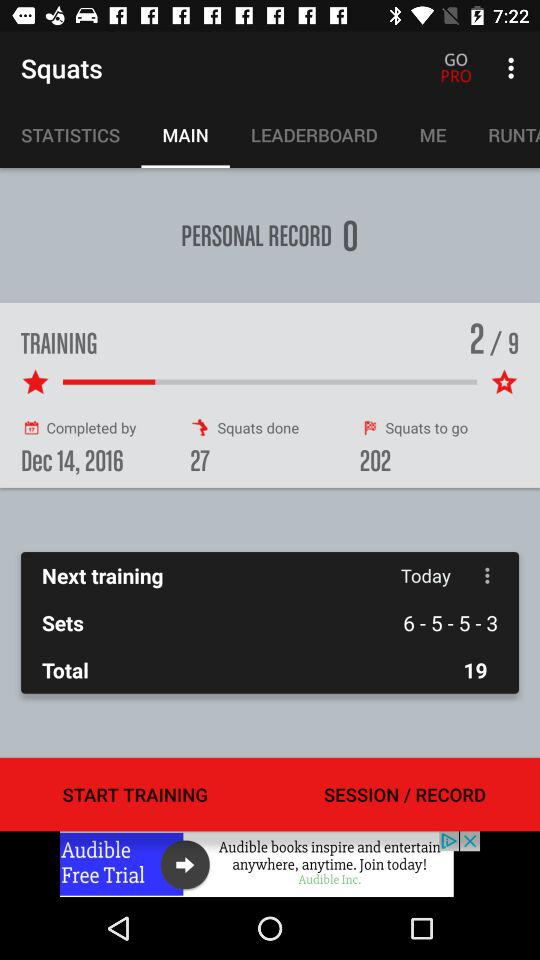How many squats are left to do?
Answer the question using a single word or phrase. 202 